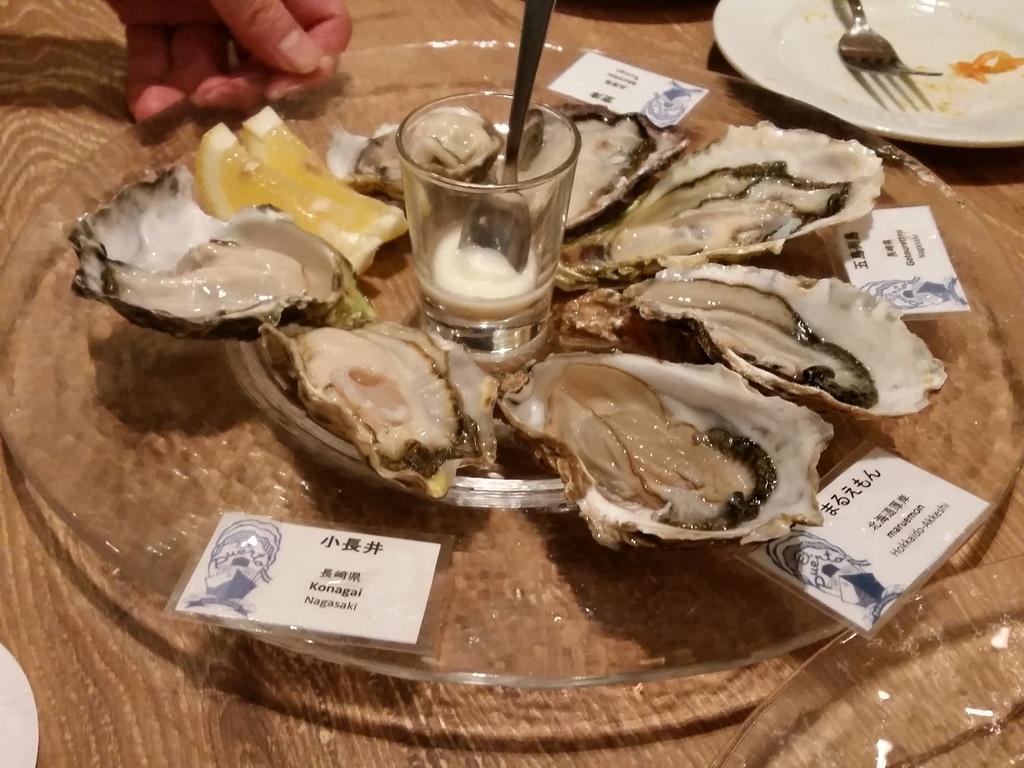Describe this image in one or two sentences. In this image, we can see some food, glass with cream and spoon are on the glass plate. Here we can see cards with some text and figures. Top of the image, we can see human hand and plate with fork and food. Background we can see a wooden surface. At the bottom of the image, we can see a few things. 